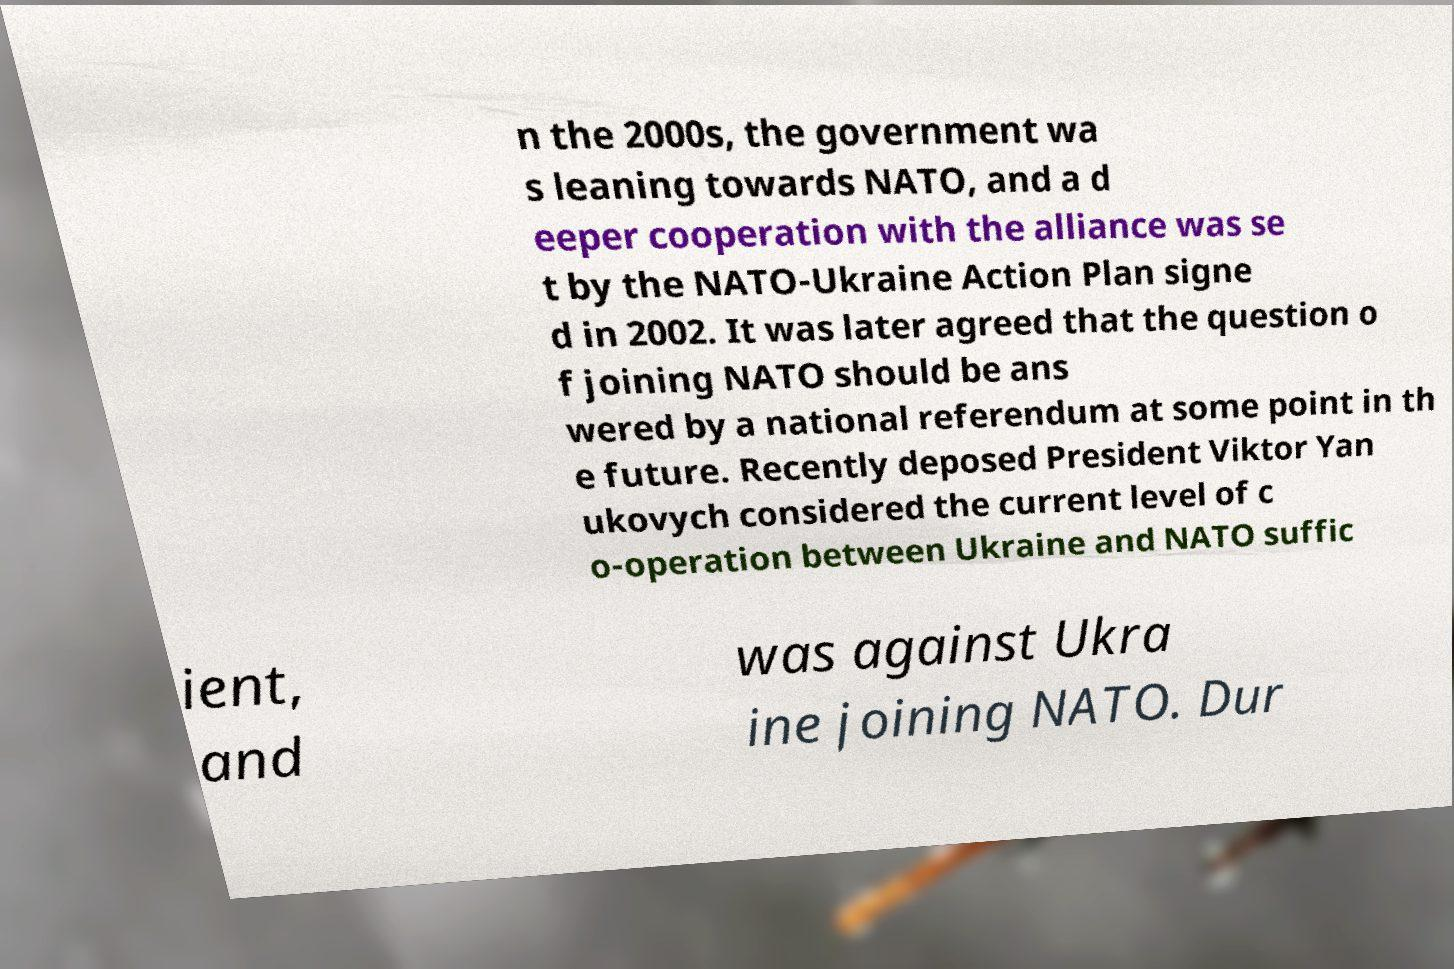Please read and relay the text visible in this image. What does it say? n the 2000s, the government wa s leaning towards NATO, and a d eeper cooperation with the alliance was se t by the NATO-Ukraine Action Plan signe d in 2002. It was later agreed that the question o f joining NATO should be ans wered by a national referendum at some point in th e future. Recently deposed President Viktor Yan ukovych considered the current level of c o-operation between Ukraine and NATO suffic ient, and was against Ukra ine joining NATO. Dur 